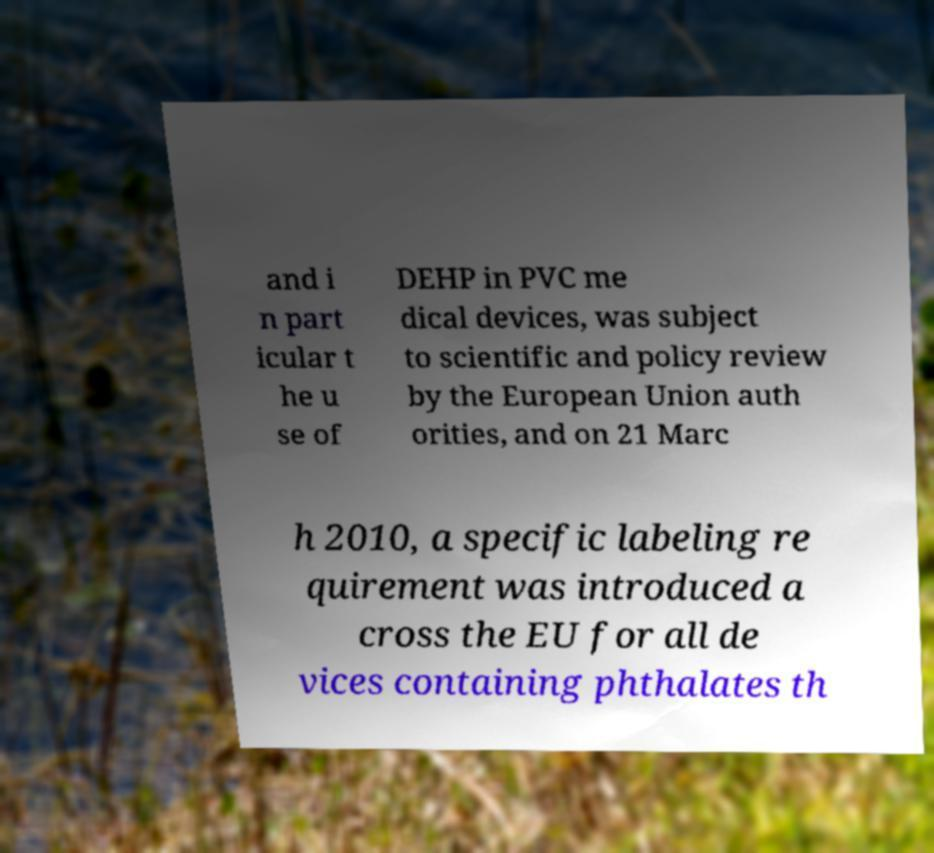For documentation purposes, I need the text within this image transcribed. Could you provide that? and i n part icular t he u se of DEHP in PVC me dical devices, was subject to scientific and policy review by the European Union auth orities, and on 21 Marc h 2010, a specific labeling re quirement was introduced a cross the EU for all de vices containing phthalates th 